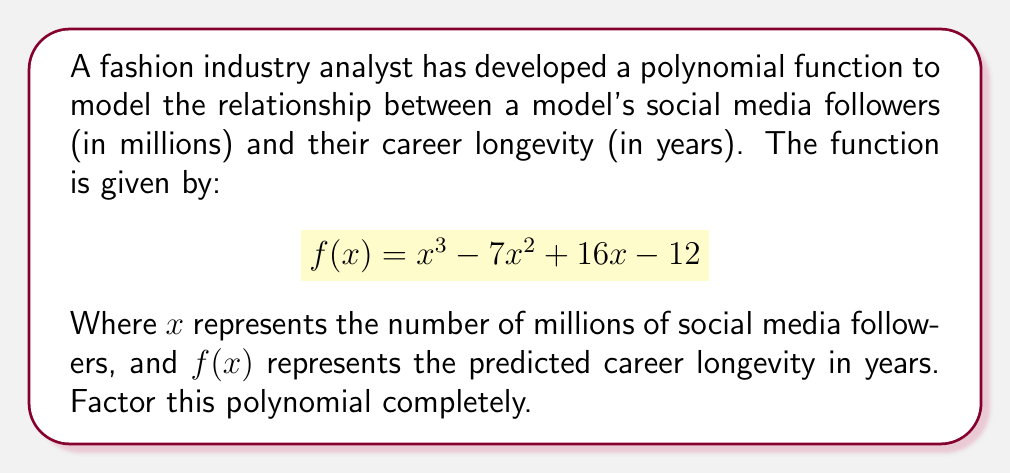What is the answer to this math problem? To factor this polynomial, we'll follow these steps:

1) First, let's check if there are any rational roots using the rational root theorem. The possible rational roots are the factors of the constant term: ±1, ±2, ±3, ±4, ±6, ±12.

2) Testing these values, we find that $f(1) = 0$. So $(x-1)$ is a factor.

3) We can use polynomial long division to divide $f(x)$ by $(x-1)$:

   $$\frac{x^3 - 7x^2 + 16x - 12}{x-1} = x^2 - 6x + 10$$

4) So now we have: $f(x) = (x-1)(x^2 - 6x + 10)$

5) The quadratic factor $x^2 - 6x + 10$ can be factored further using the quadratic formula or by recognizing it as a perfect square trinomial:

   $x^2 - 6x + 10 = (x-3)^2 + 1 = (x-3+i)(x-3-i)$

6) Therefore, the complete factorization is:

   $$f(x) = (x-1)((x-3+i)(x-3-i))$$

This factorization reveals that the polynomial has one real root at $x=1$ and two complex roots at $x=3±i$.
Answer: $f(x) = (x-1)(x-3+i)(x-3-i)$ 